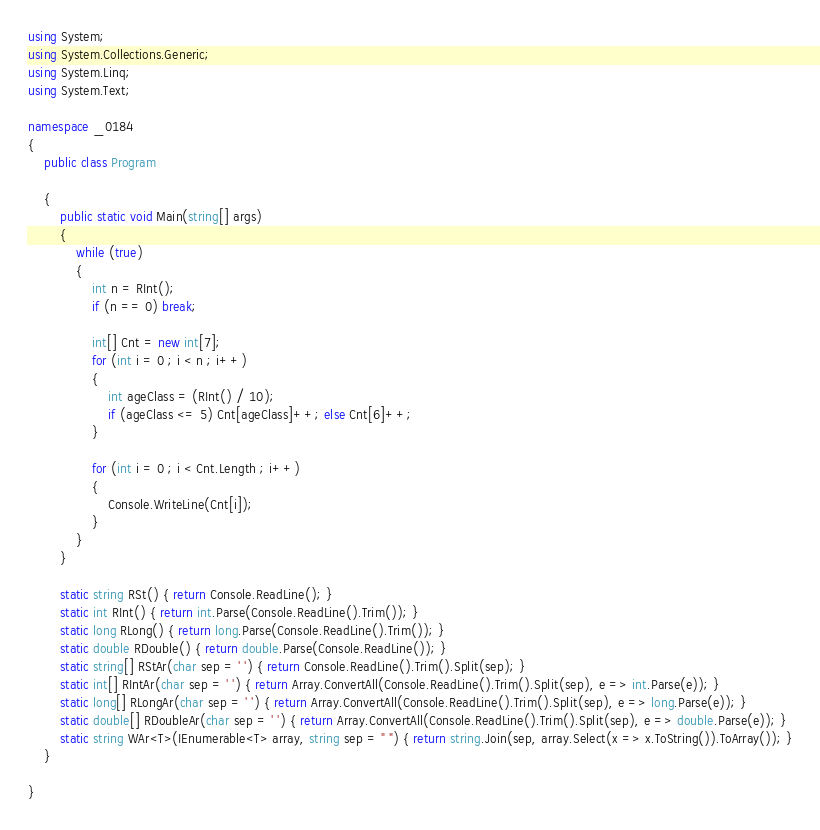Convert code to text. <code><loc_0><loc_0><loc_500><loc_500><_C#_>using System;
using System.Collections.Generic;
using System.Linq;
using System.Text;

namespace _0184
{
    public class Program

    {
        public static void Main(string[] args)
        {
            while (true)
            {
                int n = RInt();
                if (n == 0) break;

                int[] Cnt = new int[7];
                for (int i = 0 ; i < n ; i++)
                {
                    int ageClass = (RInt() / 10);
                    if (ageClass <= 5) Cnt[ageClass]++; else Cnt[6]++;
                }

                for (int i = 0 ; i < Cnt.Length ; i++)
                {
                    Console.WriteLine(Cnt[i]);
                }
            }
        }

        static string RSt() { return Console.ReadLine(); }
        static int RInt() { return int.Parse(Console.ReadLine().Trim()); }
        static long RLong() { return long.Parse(Console.ReadLine().Trim()); }
        static double RDouble() { return double.Parse(Console.ReadLine()); }
        static string[] RStAr(char sep = ' ') { return Console.ReadLine().Trim().Split(sep); }
        static int[] RIntAr(char sep = ' ') { return Array.ConvertAll(Console.ReadLine().Trim().Split(sep), e => int.Parse(e)); }
        static long[] RLongAr(char sep = ' ') { return Array.ConvertAll(Console.ReadLine().Trim().Split(sep), e => long.Parse(e)); }
        static double[] RDoubleAr(char sep = ' ') { return Array.ConvertAll(Console.ReadLine().Trim().Split(sep), e => double.Parse(e)); }
        static string WAr<T>(IEnumerable<T> array, string sep = " ") { return string.Join(sep, array.Select(x => x.ToString()).ToArray()); }
    }

}

</code> 